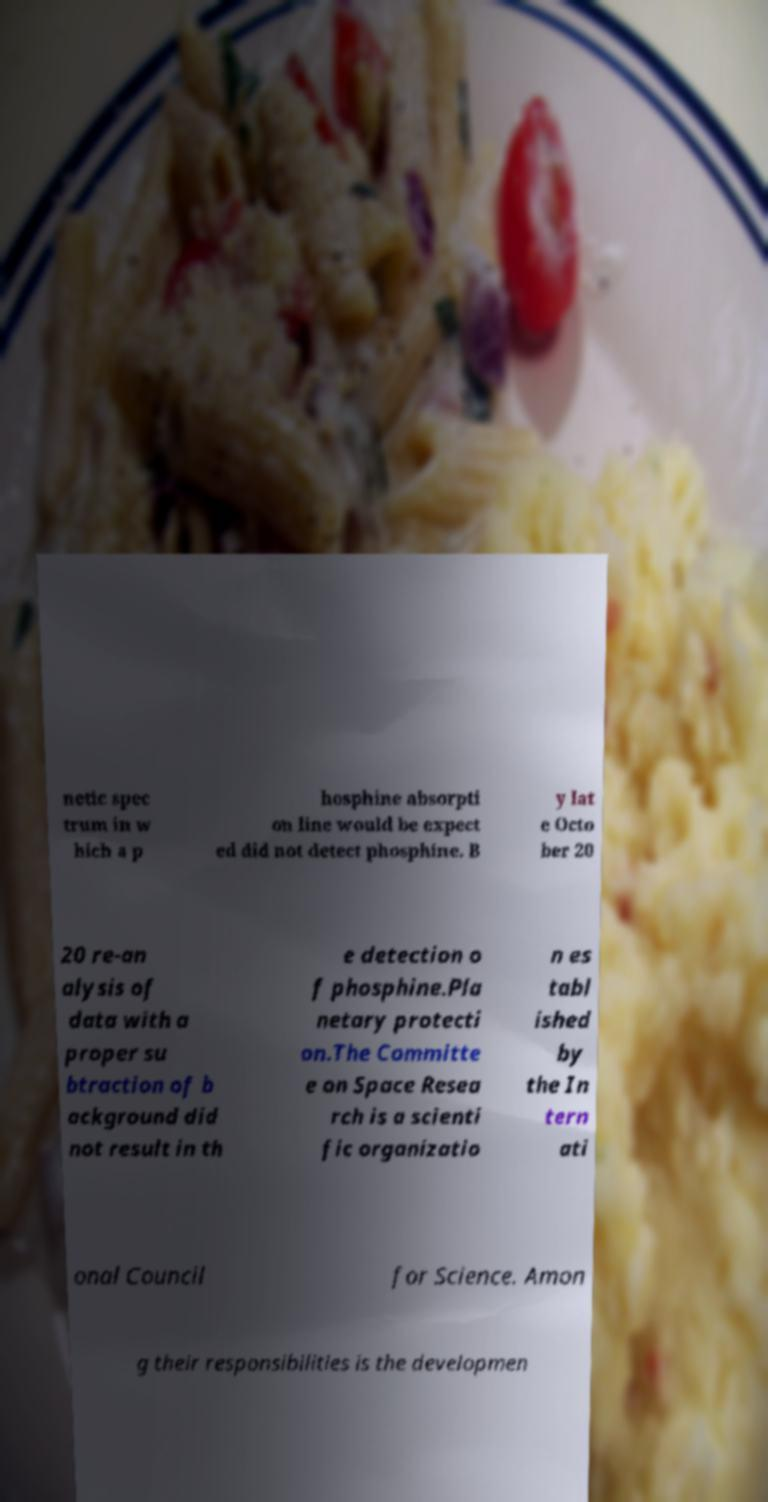There's text embedded in this image that I need extracted. Can you transcribe it verbatim? netic spec trum in w hich a p hosphine absorpti on line would be expect ed did not detect phosphine. B y lat e Octo ber 20 20 re-an alysis of data with a proper su btraction of b ackground did not result in th e detection o f phosphine.Pla netary protecti on.The Committe e on Space Resea rch is a scienti fic organizatio n es tabl ished by the In tern ati onal Council for Science. Amon g their responsibilities is the developmen 